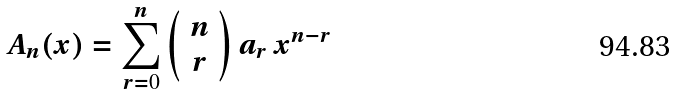<formula> <loc_0><loc_0><loc_500><loc_500>A _ { n } ( x ) = \sum _ { r = 0 } ^ { n } \left ( \begin{array} { c } n \\ r \end{array} \right ) a _ { r } \, x ^ { n - r }</formula> 